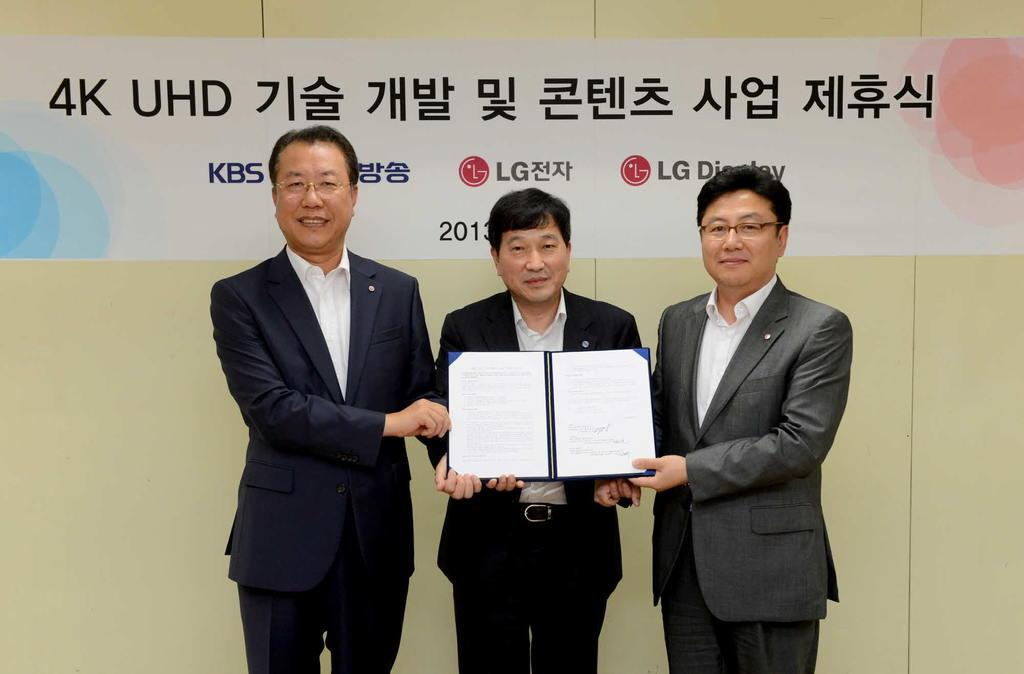How many people are in the image? There are three persons in the image. What are the persons doing in the image? The persons are standing in the image. What are the persons wearing? The persons are wearing suits. What objects are the persons holding in their hands? The persons are holding shields in their hands. What can be seen on the wall in the background? There is a banner attached to the wall in the background. What type of silver can be seen on the shields in the image? There is no silver present on the shields in the image; they are not described as being made of or containing silver. 